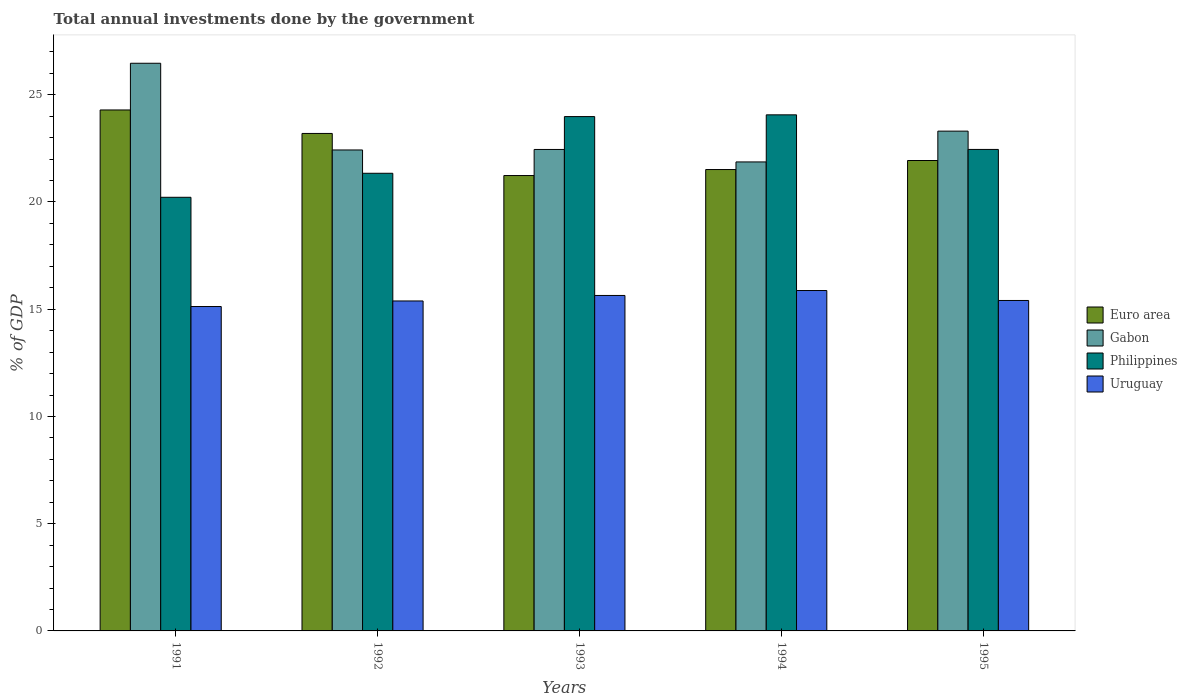How many different coloured bars are there?
Provide a succinct answer. 4. How many groups of bars are there?
Offer a terse response. 5. How many bars are there on the 1st tick from the left?
Provide a succinct answer. 4. In how many cases, is the number of bars for a given year not equal to the number of legend labels?
Offer a very short reply. 0. What is the total annual investments done by the government in Uruguay in 1991?
Your answer should be compact. 15.13. Across all years, what is the maximum total annual investments done by the government in Euro area?
Offer a terse response. 24.29. Across all years, what is the minimum total annual investments done by the government in Euro area?
Your answer should be very brief. 21.23. What is the total total annual investments done by the government in Euro area in the graph?
Make the answer very short. 112.17. What is the difference between the total annual investments done by the government in Philippines in 1991 and that in 1992?
Offer a very short reply. -1.12. What is the difference between the total annual investments done by the government in Gabon in 1991 and the total annual investments done by the government in Philippines in 1994?
Give a very brief answer. 2.41. What is the average total annual investments done by the government in Philippines per year?
Your response must be concise. 22.41. In the year 1993, what is the difference between the total annual investments done by the government in Euro area and total annual investments done by the government in Gabon?
Provide a succinct answer. -1.22. In how many years, is the total annual investments done by the government in Uruguay greater than 11 %?
Provide a succinct answer. 5. What is the ratio of the total annual investments done by the government in Gabon in 1991 to that in 1994?
Provide a short and direct response. 1.21. Is the difference between the total annual investments done by the government in Euro area in 1993 and 1995 greater than the difference between the total annual investments done by the government in Gabon in 1993 and 1995?
Your answer should be compact. Yes. What is the difference between the highest and the second highest total annual investments done by the government in Euro area?
Your answer should be very brief. 1.1. What is the difference between the highest and the lowest total annual investments done by the government in Philippines?
Keep it short and to the point. 3.84. In how many years, is the total annual investments done by the government in Gabon greater than the average total annual investments done by the government in Gabon taken over all years?
Offer a terse response. 2. Is it the case that in every year, the sum of the total annual investments done by the government in Uruguay and total annual investments done by the government in Gabon is greater than the sum of total annual investments done by the government in Philippines and total annual investments done by the government in Euro area?
Make the answer very short. No. What does the 1st bar from the left in 1995 represents?
Your answer should be compact. Euro area. Are all the bars in the graph horizontal?
Keep it short and to the point. No. Does the graph contain any zero values?
Give a very brief answer. No. How many legend labels are there?
Your response must be concise. 4. How are the legend labels stacked?
Make the answer very short. Vertical. What is the title of the graph?
Your answer should be compact. Total annual investments done by the government. Does "Comoros" appear as one of the legend labels in the graph?
Your response must be concise. No. What is the label or title of the X-axis?
Provide a succinct answer. Years. What is the label or title of the Y-axis?
Provide a short and direct response. % of GDP. What is the % of GDP of Euro area in 1991?
Provide a succinct answer. 24.29. What is the % of GDP in Gabon in 1991?
Your answer should be very brief. 26.47. What is the % of GDP of Philippines in 1991?
Offer a terse response. 20.22. What is the % of GDP in Uruguay in 1991?
Provide a short and direct response. 15.13. What is the % of GDP in Euro area in 1992?
Keep it short and to the point. 23.2. What is the % of GDP in Gabon in 1992?
Provide a short and direct response. 22.43. What is the % of GDP in Philippines in 1992?
Keep it short and to the point. 21.34. What is the % of GDP in Uruguay in 1992?
Your answer should be compact. 15.38. What is the % of GDP of Euro area in 1993?
Keep it short and to the point. 21.23. What is the % of GDP in Gabon in 1993?
Keep it short and to the point. 22.45. What is the % of GDP of Philippines in 1993?
Provide a short and direct response. 23.98. What is the % of GDP of Uruguay in 1993?
Ensure brevity in your answer.  15.64. What is the % of GDP of Euro area in 1994?
Provide a succinct answer. 21.51. What is the % of GDP in Gabon in 1994?
Provide a short and direct response. 21.87. What is the % of GDP in Philippines in 1994?
Your response must be concise. 24.06. What is the % of GDP of Uruguay in 1994?
Keep it short and to the point. 15.87. What is the % of GDP in Euro area in 1995?
Your response must be concise. 21.93. What is the % of GDP in Gabon in 1995?
Give a very brief answer. 23.3. What is the % of GDP in Philippines in 1995?
Offer a terse response. 22.45. What is the % of GDP in Uruguay in 1995?
Ensure brevity in your answer.  15.41. Across all years, what is the maximum % of GDP in Euro area?
Ensure brevity in your answer.  24.29. Across all years, what is the maximum % of GDP of Gabon?
Your answer should be compact. 26.47. Across all years, what is the maximum % of GDP in Philippines?
Your response must be concise. 24.06. Across all years, what is the maximum % of GDP of Uruguay?
Provide a short and direct response. 15.87. Across all years, what is the minimum % of GDP of Euro area?
Give a very brief answer. 21.23. Across all years, what is the minimum % of GDP of Gabon?
Your answer should be compact. 21.87. Across all years, what is the minimum % of GDP of Philippines?
Keep it short and to the point. 20.22. Across all years, what is the minimum % of GDP of Uruguay?
Make the answer very short. 15.13. What is the total % of GDP in Euro area in the graph?
Ensure brevity in your answer.  112.17. What is the total % of GDP of Gabon in the graph?
Your answer should be very brief. 116.51. What is the total % of GDP in Philippines in the graph?
Your response must be concise. 112.05. What is the total % of GDP in Uruguay in the graph?
Provide a short and direct response. 77.43. What is the difference between the % of GDP in Euro area in 1991 and that in 1992?
Give a very brief answer. 1.1. What is the difference between the % of GDP in Gabon in 1991 and that in 1992?
Provide a short and direct response. 4.04. What is the difference between the % of GDP in Philippines in 1991 and that in 1992?
Make the answer very short. -1.12. What is the difference between the % of GDP of Uruguay in 1991 and that in 1992?
Keep it short and to the point. -0.26. What is the difference between the % of GDP in Euro area in 1991 and that in 1993?
Provide a succinct answer. 3.06. What is the difference between the % of GDP of Gabon in 1991 and that in 1993?
Provide a short and direct response. 4.02. What is the difference between the % of GDP of Philippines in 1991 and that in 1993?
Ensure brevity in your answer.  -3.76. What is the difference between the % of GDP in Uruguay in 1991 and that in 1993?
Give a very brief answer. -0.52. What is the difference between the % of GDP of Euro area in 1991 and that in 1994?
Offer a terse response. 2.78. What is the difference between the % of GDP in Gabon in 1991 and that in 1994?
Ensure brevity in your answer.  4.6. What is the difference between the % of GDP in Philippines in 1991 and that in 1994?
Provide a short and direct response. -3.84. What is the difference between the % of GDP of Uruguay in 1991 and that in 1994?
Provide a succinct answer. -0.75. What is the difference between the % of GDP in Euro area in 1991 and that in 1995?
Keep it short and to the point. 2.36. What is the difference between the % of GDP in Gabon in 1991 and that in 1995?
Your response must be concise. 3.16. What is the difference between the % of GDP in Philippines in 1991 and that in 1995?
Provide a succinct answer. -2.23. What is the difference between the % of GDP in Uruguay in 1991 and that in 1995?
Your response must be concise. -0.28. What is the difference between the % of GDP in Euro area in 1992 and that in 1993?
Provide a succinct answer. 1.96. What is the difference between the % of GDP in Gabon in 1992 and that in 1993?
Your answer should be compact. -0.02. What is the difference between the % of GDP in Philippines in 1992 and that in 1993?
Keep it short and to the point. -2.64. What is the difference between the % of GDP in Uruguay in 1992 and that in 1993?
Provide a short and direct response. -0.26. What is the difference between the % of GDP of Euro area in 1992 and that in 1994?
Your answer should be very brief. 1.68. What is the difference between the % of GDP in Gabon in 1992 and that in 1994?
Your answer should be very brief. 0.56. What is the difference between the % of GDP of Philippines in 1992 and that in 1994?
Your answer should be compact. -2.72. What is the difference between the % of GDP of Uruguay in 1992 and that in 1994?
Give a very brief answer. -0.49. What is the difference between the % of GDP in Euro area in 1992 and that in 1995?
Provide a succinct answer. 1.26. What is the difference between the % of GDP in Gabon in 1992 and that in 1995?
Provide a succinct answer. -0.88. What is the difference between the % of GDP in Philippines in 1992 and that in 1995?
Ensure brevity in your answer.  -1.11. What is the difference between the % of GDP of Uruguay in 1992 and that in 1995?
Keep it short and to the point. -0.02. What is the difference between the % of GDP of Euro area in 1993 and that in 1994?
Your answer should be very brief. -0.28. What is the difference between the % of GDP in Gabon in 1993 and that in 1994?
Ensure brevity in your answer.  0.58. What is the difference between the % of GDP of Philippines in 1993 and that in 1994?
Offer a terse response. -0.08. What is the difference between the % of GDP of Uruguay in 1993 and that in 1994?
Give a very brief answer. -0.23. What is the difference between the % of GDP of Euro area in 1993 and that in 1995?
Provide a short and direct response. -0.7. What is the difference between the % of GDP of Gabon in 1993 and that in 1995?
Your answer should be compact. -0.85. What is the difference between the % of GDP in Philippines in 1993 and that in 1995?
Provide a succinct answer. 1.53. What is the difference between the % of GDP of Uruguay in 1993 and that in 1995?
Your answer should be very brief. 0.23. What is the difference between the % of GDP of Euro area in 1994 and that in 1995?
Your answer should be compact. -0.42. What is the difference between the % of GDP of Gabon in 1994 and that in 1995?
Keep it short and to the point. -1.44. What is the difference between the % of GDP in Philippines in 1994 and that in 1995?
Your answer should be very brief. 1.61. What is the difference between the % of GDP of Uruguay in 1994 and that in 1995?
Make the answer very short. 0.46. What is the difference between the % of GDP of Euro area in 1991 and the % of GDP of Gabon in 1992?
Offer a terse response. 1.87. What is the difference between the % of GDP in Euro area in 1991 and the % of GDP in Philippines in 1992?
Your answer should be very brief. 2.95. What is the difference between the % of GDP of Euro area in 1991 and the % of GDP of Uruguay in 1992?
Your answer should be compact. 8.91. What is the difference between the % of GDP of Gabon in 1991 and the % of GDP of Philippines in 1992?
Your answer should be very brief. 5.13. What is the difference between the % of GDP in Gabon in 1991 and the % of GDP in Uruguay in 1992?
Provide a succinct answer. 11.08. What is the difference between the % of GDP in Philippines in 1991 and the % of GDP in Uruguay in 1992?
Offer a very short reply. 4.83. What is the difference between the % of GDP in Euro area in 1991 and the % of GDP in Gabon in 1993?
Provide a short and direct response. 1.84. What is the difference between the % of GDP of Euro area in 1991 and the % of GDP of Philippines in 1993?
Make the answer very short. 0.31. What is the difference between the % of GDP in Euro area in 1991 and the % of GDP in Uruguay in 1993?
Provide a succinct answer. 8.65. What is the difference between the % of GDP of Gabon in 1991 and the % of GDP of Philippines in 1993?
Your response must be concise. 2.49. What is the difference between the % of GDP in Gabon in 1991 and the % of GDP in Uruguay in 1993?
Give a very brief answer. 10.83. What is the difference between the % of GDP in Philippines in 1991 and the % of GDP in Uruguay in 1993?
Your answer should be very brief. 4.58. What is the difference between the % of GDP of Euro area in 1991 and the % of GDP of Gabon in 1994?
Your answer should be compact. 2.42. What is the difference between the % of GDP of Euro area in 1991 and the % of GDP of Philippines in 1994?
Keep it short and to the point. 0.23. What is the difference between the % of GDP in Euro area in 1991 and the % of GDP in Uruguay in 1994?
Provide a succinct answer. 8.42. What is the difference between the % of GDP in Gabon in 1991 and the % of GDP in Philippines in 1994?
Make the answer very short. 2.41. What is the difference between the % of GDP of Gabon in 1991 and the % of GDP of Uruguay in 1994?
Your response must be concise. 10.6. What is the difference between the % of GDP in Philippines in 1991 and the % of GDP in Uruguay in 1994?
Make the answer very short. 4.35. What is the difference between the % of GDP in Euro area in 1991 and the % of GDP in Gabon in 1995?
Your answer should be compact. 0.99. What is the difference between the % of GDP of Euro area in 1991 and the % of GDP of Philippines in 1995?
Ensure brevity in your answer.  1.84. What is the difference between the % of GDP in Euro area in 1991 and the % of GDP in Uruguay in 1995?
Your answer should be very brief. 8.88. What is the difference between the % of GDP in Gabon in 1991 and the % of GDP in Philippines in 1995?
Provide a succinct answer. 4.02. What is the difference between the % of GDP in Gabon in 1991 and the % of GDP in Uruguay in 1995?
Your response must be concise. 11.06. What is the difference between the % of GDP of Philippines in 1991 and the % of GDP of Uruguay in 1995?
Offer a very short reply. 4.81. What is the difference between the % of GDP of Euro area in 1992 and the % of GDP of Gabon in 1993?
Your answer should be compact. 0.75. What is the difference between the % of GDP in Euro area in 1992 and the % of GDP in Philippines in 1993?
Ensure brevity in your answer.  -0.79. What is the difference between the % of GDP in Euro area in 1992 and the % of GDP in Uruguay in 1993?
Give a very brief answer. 7.55. What is the difference between the % of GDP of Gabon in 1992 and the % of GDP of Philippines in 1993?
Provide a short and direct response. -1.56. What is the difference between the % of GDP in Gabon in 1992 and the % of GDP in Uruguay in 1993?
Provide a succinct answer. 6.78. What is the difference between the % of GDP of Philippines in 1992 and the % of GDP of Uruguay in 1993?
Provide a succinct answer. 5.7. What is the difference between the % of GDP of Euro area in 1992 and the % of GDP of Gabon in 1994?
Your answer should be very brief. 1.33. What is the difference between the % of GDP of Euro area in 1992 and the % of GDP of Philippines in 1994?
Your response must be concise. -0.87. What is the difference between the % of GDP in Euro area in 1992 and the % of GDP in Uruguay in 1994?
Give a very brief answer. 7.32. What is the difference between the % of GDP in Gabon in 1992 and the % of GDP in Philippines in 1994?
Your answer should be very brief. -1.64. What is the difference between the % of GDP in Gabon in 1992 and the % of GDP in Uruguay in 1994?
Offer a very short reply. 6.55. What is the difference between the % of GDP in Philippines in 1992 and the % of GDP in Uruguay in 1994?
Make the answer very short. 5.47. What is the difference between the % of GDP in Euro area in 1992 and the % of GDP in Gabon in 1995?
Offer a terse response. -0.11. What is the difference between the % of GDP of Euro area in 1992 and the % of GDP of Philippines in 1995?
Give a very brief answer. 0.74. What is the difference between the % of GDP in Euro area in 1992 and the % of GDP in Uruguay in 1995?
Make the answer very short. 7.79. What is the difference between the % of GDP in Gabon in 1992 and the % of GDP in Philippines in 1995?
Make the answer very short. -0.03. What is the difference between the % of GDP in Gabon in 1992 and the % of GDP in Uruguay in 1995?
Your answer should be very brief. 7.02. What is the difference between the % of GDP of Philippines in 1992 and the % of GDP of Uruguay in 1995?
Your response must be concise. 5.93. What is the difference between the % of GDP of Euro area in 1993 and the % of GDP of Gabon in 1994?
Provide a short and direct response. -0.64. What is the difference between the % of GDP of Euro area in 1993 and the % of GDP of Philippines in 1994?
Ensure brevity in your answer.  -2.83. What is the difference between the % of GDP in Euro area in 1993 and the % of GDP in Uruguay in 1994?
Your response must be concise. 5.36. What is the difference between the % of GDP in Gabon in 1993 and the % of GDP in Philippines in 1994?
Your answer should be very brief. -1.61. What is the difference between the % of GDP of Gabon in 1993 and the % of GDP of Uruguay in 1994?
Make the answer very short. 6.58. What is the difference between the % of GDP of Philippines in 1993 and the % of GDP of Uruguay in 1994?
Your response must be concise. 8.11. What is the difference between the % of GDP in Euro area in 1993 and the % of GDP in Gabon in 1995?
Offer a very short reply. -2.07. What is the difference between the % of GDP in Euro area in 1993 and the % of GDP in Philippines in 1995?
Your answer should be compact. -1.22. What is the difference between the % of GDP of Euro area in 1993 and the % of GDP of Uruguay in 1995?
Provide a short and direct response. 5.82. What is the difference between the % of GDP of Gabon in 1993 and the % of GDP of Philippines in 1995?
Offer a very short reply. -0. What is the difference between the % of GDP in Gabon in 1993 and the % of GDP in Uruguay in 1995?
Make the answer very short. 7.04. What is the difference between the % of GDP in Philippines in 1993 and the % of GDP in Uruguay in 1995?
Give a very brief answer. 8.57. What is the difference between the % of GDP of Euro area in 1994 and the % of GDP of Gabon in 1995?
Provide a succinct answer. -1.79. What is the difference between the % of GDP of Euro area in 1994 and the % of GDP of Philippines in 1995?
Offer a very short reply. -0.94. What is the difference between the % of GDP in Euro area in 1994 and the % of GDP in Uruguay in 1995?
Your response must be concise. 6.11. What is the difference between the % of GDP in Gabon in 1994 and the % of GDP in Philippines in 1995?
Provide a succinct answer. -0.58. What is the difference between the % of GDP of Gabon in 1994 and the % of GDP of Uruguay in 1995?
Your response must be concise. 6.46. What is the difference between the % of GDP of Philippines in 1994 and the % of GDP of Uruguay in 1995?
Ensure brevity in your answer.  8.66. What is the average % of GDP of Euro area per year?
Offer a very short reply. 22.43. What is the average % of GDP of Gabon per year?
Offer a terse response. 23.3. What is the average % of GDP in Philippines per year?
Ensure brevity in your answer.  22.41. What is the average % of GDP in Uruguay per year?
Your answer should be very brief. 15.49. In the year 1991, what is the difference between the % of GDP in Euro area and % of GDP in Gabon?
Your answer should be very brief. -2.18. In the year 1991, what is the difference between the % of GDP of Euro area and % of GDP of Philippines?
Offer a very short reply. 4.07. In the year 1991, what is the difference between the % of GDP of Euro area and % of GDP of Uruguay?
Offer a very short reply. 9.17. In the year 1991, what is the difference between the % of GDP of Gabon and % of GDP of Philippines?
Ensure brevity in your answer.  6.25. In the year 1991, what is the difference between the % of GDP of Gabon and % of GDP of Uruguay?
Ensure brevity in your answer.  11.34. In the year 1991, what is the difference between the % of GDP of Philippines and % of GDP of Uruguay?
Offer a terse response. 5.09. In the year 1992, what is the difference between the % of GDP of Euro area and % of GDP of Gabon?
Your answer should be very brief. 0.77. In the year 1992, what is the difference between the % of GDP in Euro area and % of GDP in Philippines?
Ensure brevity in your answer.  1.86. In the year 1992, what is the difference between the % of GDP of Euro area and % of GDP of Uruguay?
Keep it short and to the point. 7.81. In the year 1992, what is the difference between the % of GDP in Gabon and % of GDP in Philippines?
Make the answer very short. 1.09. In the year 1992, what is the difference between the % of GDP in Gabon and % of GDP in Uruguay?
Provide a succinct answer. 7.04. In the year 1992, what is the difference between the % of GDP in Philippines and % of GDP in Uruguay?
Your answer should be compact. 5.95. In the year 1993, what is the difference between the % of GDP of Euro area and % of GDP of Gabon?
Give a very brief answer. -1.22. In the year 1993, what is the difference between the % of GDP of Euro area and % of GDP of Philippines?
Offer a very short reply. -2.75. In the year 1993, what is the difference between the % of GDP in Euro area and % of GDP in Uruguay?
Offer a terse response. 5.59. In the year 1993, what is the difference between the % of GDP of Gabon and % of GDP of Philippines?
Provide a short and direct response. -1.53. In the year 1993, what is the difference between the % of GDP of Gabon and % of GDP of Uruguay?
Offer a very short reply. 6.81. In the year 1993, what is the difference between the % of GDP of Philippines and % of GDP of Uruguay?
Make the answer very short. 8.34. In the year 1994, what is the difference between the % of GDP in Euro area and % of GDP in Gabon?
Ensure brevity in your answer.  -0.35. In the year 1994, what is the difference between the % of GDP of Euro area and % of GDP of Philippines?
Keep it short and to the point. -2.55. In the year 1994, what is the difference between the % of GDP in Euro area and % of GDP in Uruguay?
Your answer should be very brief. 5.64. In the year 1994, what is the difference between the % of GDP in Gabon and % of GDP in Philippines?
Provide a short and direct response. -2.2. In the year 1994, what is the difference between the % of GDP in Gabon and % of GDP in Uruguay?
Make the answer very short. 6. In the year 1994, what is the difference between the % of GDP of Philippines and % of GDP of Uruguay?
Make the answer very short. 8.19. In the year 1995, what is the difference between the % of GDP of Euro area and % of GDP of Gabon?
Ensure brevity in your answer.  -1.37. In the year 1995, what is the difference between the % of GDP in Euro area and % of GDP in Philippines?
Provide a succinct answer. -0.52. In the year 1995, what is the difference between the % of GDP of Euro area and % of GDP of Uruguay?
Offer a very short reply. 6.53. In the year 1995, what is the difference between the % of GDP in Gabon and % of GDP in Philippines?
Your answer should be compact. 0.85. In the year 1995, what is the difference between the % of GDP in Gabon and % of GDP in Uruguay?
Your answer should be compact. 7.9. In the year 1995, what is the difference between the % of GDP of Philippines and % of GDP of Uruguay?
Offer a very short reply. 7.04. What is the ratio of the % of GDP in Euro area in 1991 to that in 1992?
Your response must be concise. 1.05. What is the ratio of the % of GDP in Gabon in 1991 to that in 1992?
Your response must be concise. 1.18. What is the ratio of the % of GDP of Philippines in 1991 to that in 1992?
Keep it short and to the point. 0.95. What is the ratio of the % of GDP of Uruguay in 1991 to that in 1992?
Provide a short and direct response. 0.98. What is the ratio of the % of GDP in Euro area in 1991 to that in 1993?
Provide a short and direct response. 1.14. What is the ratio of the % of GDP of Gabon in 1991 to that in 1993?
Provide a succinct answer. 1.18. What is the ratio of the % of GDP in Philippines in 1991 to that in 1993?
Provide a short and direct response. 0.84. What is the ratio of the % of GDP of Euro area in 1991 to that in 1994?
Your answer should be very brief. 1.13. What is the ratio of the % of GDP in Gabon in 1991 to that in 1994?
Your answer should be compact. 1.21. What is the ratio of the % of GDP in Philippines in 1991 to that in 1994?
Ensure brevity in your answer.  0.84. What is the ratio of the % of GDP of Uruguay in 1991 to that in 1994?
Ensure brevity in your answer.  0.95. What is the ratio of the % of GDP of Euro area in 1991 to that in 1995?
Give a very brief answer. 1.11. What is the ratio of the % of GDP of Gabon in 1991 to that in 1995?
Ensure brevity in your answer.  1.14. What is the ratio of the % of GDP of Philippines in 1991 to that in 1995?
Your answer should be very brief. 0.9. What is the ratio of the % of GDP in Uruguay in 1991 to that in 1995?
Your answer should be very brief. 0.98. What is the ratio of the % of GDP of Euro area in 1992 to that in 1993?
Make the answer very short. 1.09. What is the ratio of the % of GDP in Philippines in 1992 to that in 1993?
Make the answer very short. 0.89. What is the ratio of the % of GDP in Uruguay in 1992 to that in 1993?
Ensure brevity in your answer.  0.98. What is the ratio of the % of GDP of Euro area in 1992 to that in 1994?
Make the answer very short. 1.08. What is the ratio of the % of GDP in Gabon in 1992 to that in 1994?
Your answer should be very brief. 1.03. What is the ratio of the % of GDP in Philippines in 1992 to that in 1994?
Offer a terse response. 0.89. What is the ratio of the % of GDP of Uruguay in 1992 to that in 1994?
Offer a terse response. 0.97. What is the ratio of the % of GDP in Euro area in 1992 to that in 1995?
Make the answer very short. 1.06. What is the ratio of the % of GDP in Gabon in 1992 to that in 1995?
Your answer should be compact. 0.96. What is the ratio of the % of GDP of Philippines in 1992 to that in 1995?
Provide a short and direct response. 0.95. What is the ratio of the % of GDP in Euro area in 1993 to that in 1994?
Provide a short and direct response. 0.99. What is the ratio of the % of GDP of Gabon in 1993 to that in 1994?
Provide a succinct answer. 1.03. What is the ratio of the % of GDP of Uruguay in 1993 to that in 1994?
Provide a short and direct response. 0.99. What is the ratio of the % of GDP in Euro area in 1993 to that in 1995?
Offer a terse response. 0.97. What is the ratio of the % of GDP in Gabon in 1993 to that in 1995?
Keep it short and to the point. 0.96. What is the ratio of the % of GDP of Philippines in 1993 to that in 1995?
Give a very brief answer. 1.07. What is the ratio of the % of GDP in Uruguay in 1993 to that in 1995?
Ensure brevity in your answer.  1.02. What is the ratio of the % of GDP of Euro area in 1994 to that in 1995?
Offer a terse response. 0.98. What is the ratio of the % of GDP of Gabon in 1994 to that in 1995?
Give a very brief answer. 0.94. What is the ratio of the % of GDP in Philippines in 1994 to that in 1995?
Your answer should be very brief. 1.07. What is the ratio of the % of GDP of Uruguay in 1994 to that in 1995?
Make the answer very short. 1.03. What is the difference between the highest and the second highest % of GDP of Euro area?
Offer a very short reply. 1.1. What is the difference between the highest and the second highest % of GDP of Gabon?
Your answer should be very brief. 3.16. What is the difference between the highest and the second highest % of GDP in Philippines?
Give a very brief answer. 0.08. What is the difference between the highest and the second highest % of GDP in Uruguay?
Your answer should be compact. 0.23. What is the difference between the highest and the lowest % of GDP in Euro area?
Ensure brevity in your answer.  3.06. What is the difference between the highest and the lowest % of GDP of Gabon?
Ensure brevity in your answer.  4.6. What is the difference between the highest and the lowest % of GDP in Philippines?
Offer a very short reply. 3.84. What is the difference between the highest and the lowest % of GDP in Uruguay?
Your response must be concise. 0.75. 